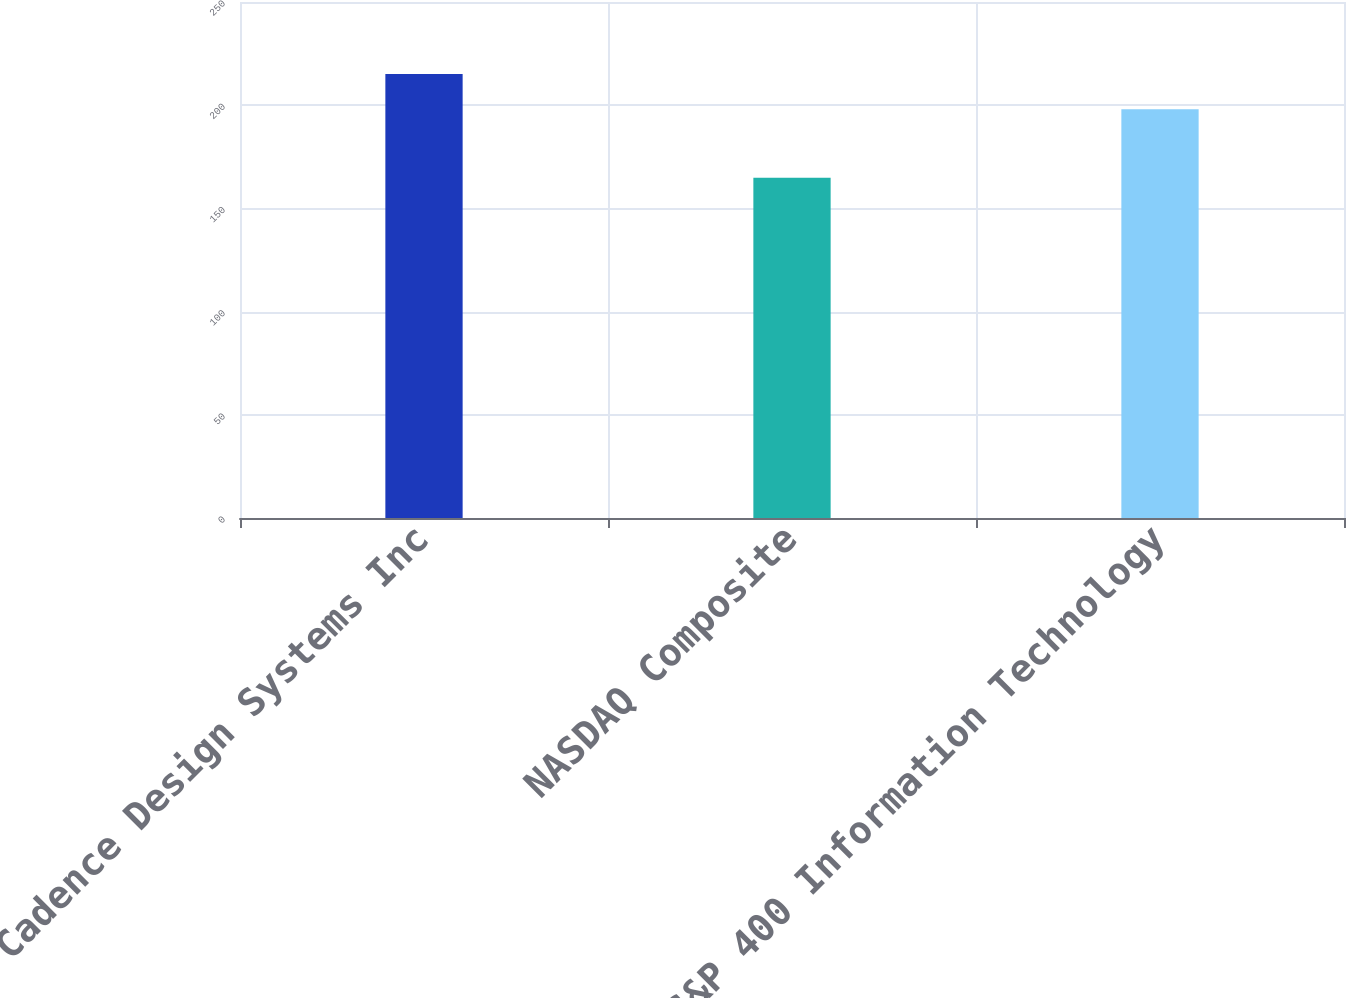Convert chart to OTSL. <chart><loc_0><loc_0><loc_500><loc_500><bar_chart><fcel>Cadence Design Systems Inc<fcel>NASDAQ Composite<fcel>S&P 400 Information Technology<nl><fcel>215.1<fcel>164.84<fcel>198.02<nl></chart> 